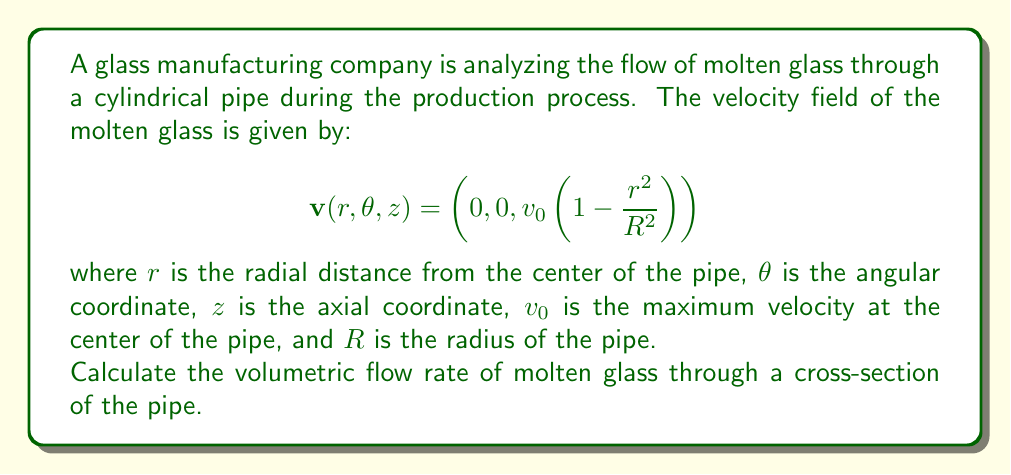Can you answer this question? To solve this problem, we need to use multivariable calculus and cylindrical coordinates. Let's approach this step-by-step:

1) The volumetric flow rate is given by the surface integral of the velocity field over the cross-section of the pipe:

   $$Q = \iint_S \mathbf{v} \cdot \mathbf{n} \, dS$$

   where $\mathbf{n}$ is the unit normal vector to the surface.

2) In this case, the surface is a circle perpendicular to the z-axis, so $\mathbf{n} = (0, 0, 1)$.

3) The dot product $\mathbf{v} \cdot \mathbf{n}$ simplifies to just the z-component of $\mathbf{v}$:

   $$\mathbf{v} \cdot \mathbf{n} = v_0\left(1 - \frac{r^2}{R^2}\right)$$

4) In cylindrical coordinates, the surface element $dS = r \, dr \, d\theta$.

5) Now we can set up our double integral:

   $$Q = \int_0^{2\pi} \int_0^R v_0\left(1 - \frac{r^2}{R^2}\right) r \, dr \, d\theta$$

6) Let's solve the inner integral first:

   $$\int_0^R v_0\left(1 - \frac{r^2}{R^2}\right) r \, dr = v_0 \left[\frac{r^2}{2} - \frac{r^4}{4R^2}\right]_0^R = v_0 \left(\frac{R^2}{2} - \frac{R^4}{4R^2}\right) = \frac{v_0R^2}{4}$$

7) Now for the outer integral:

   $$Q = \int_0^{2\pi} \frac{v_0R^2}{4} \, d\theta = \frac{v_0R^2}{4} \cdot 2\pi = \frac{\pi v_0R^2}{2}$$

This gives us the final result for the volumetric flow rate.
Answer: The volumetric flow rate of molten glass through a cross-section of the pipe is:

$$Q = \frac{\pi v_0R^2}{2}$$

where $v_0$ is the maximum velocity at the center of the pipe and $R$ is the radius of the pipe. 